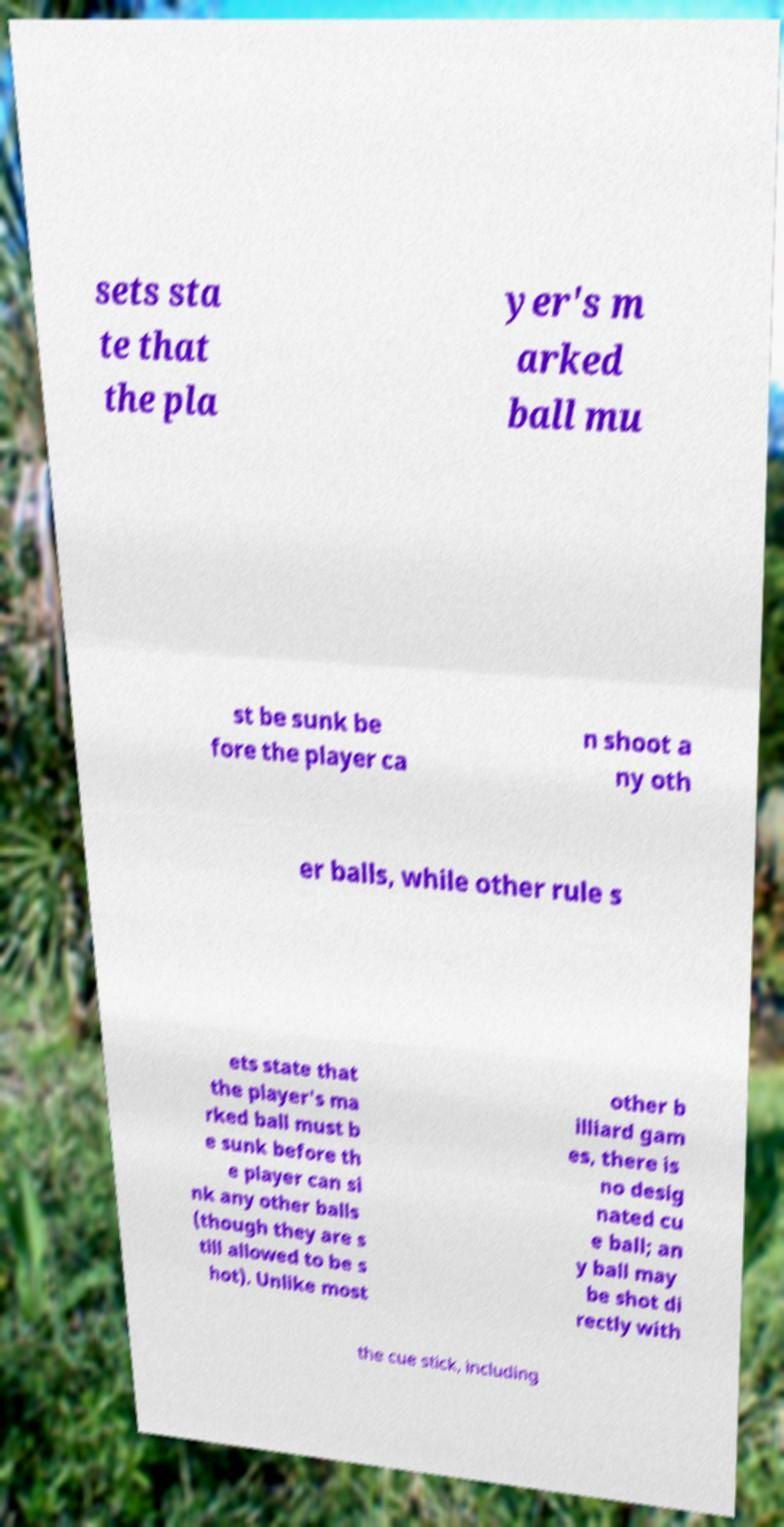Could you assist in decoding the text presented in this image and type it out clearly? sets sta te that the pla yer's m arked ball mu st be sunk be fore the player ca n shoot a ny oth er balls, while other rule s ets state that the player's ma rked ball must b e sunk before th e player can si nk any other balls (though they are s till allowed to be s hot). Unlike most other b illiard gam es, there is no desig nated cu e ball; an y ball may be shot di rectly with the cue stick, including 